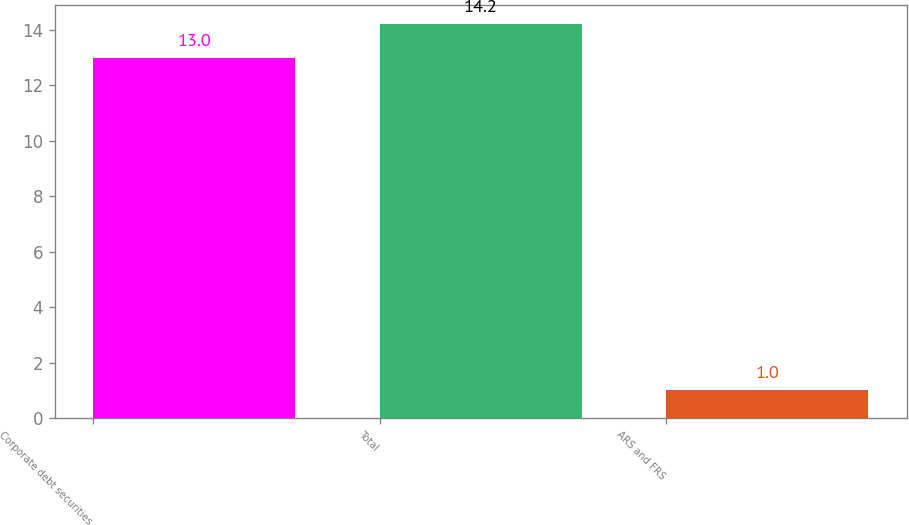Convert chart to OTSL. <chart><loc_0><loc_0><loc_500><loc_500><bar_chart><fcel>Corporate debt securities<fcel>Total<fcel>ARS and FRS<nl><fcel>13<fcel>14.2<fcel>1<nl></chart> 